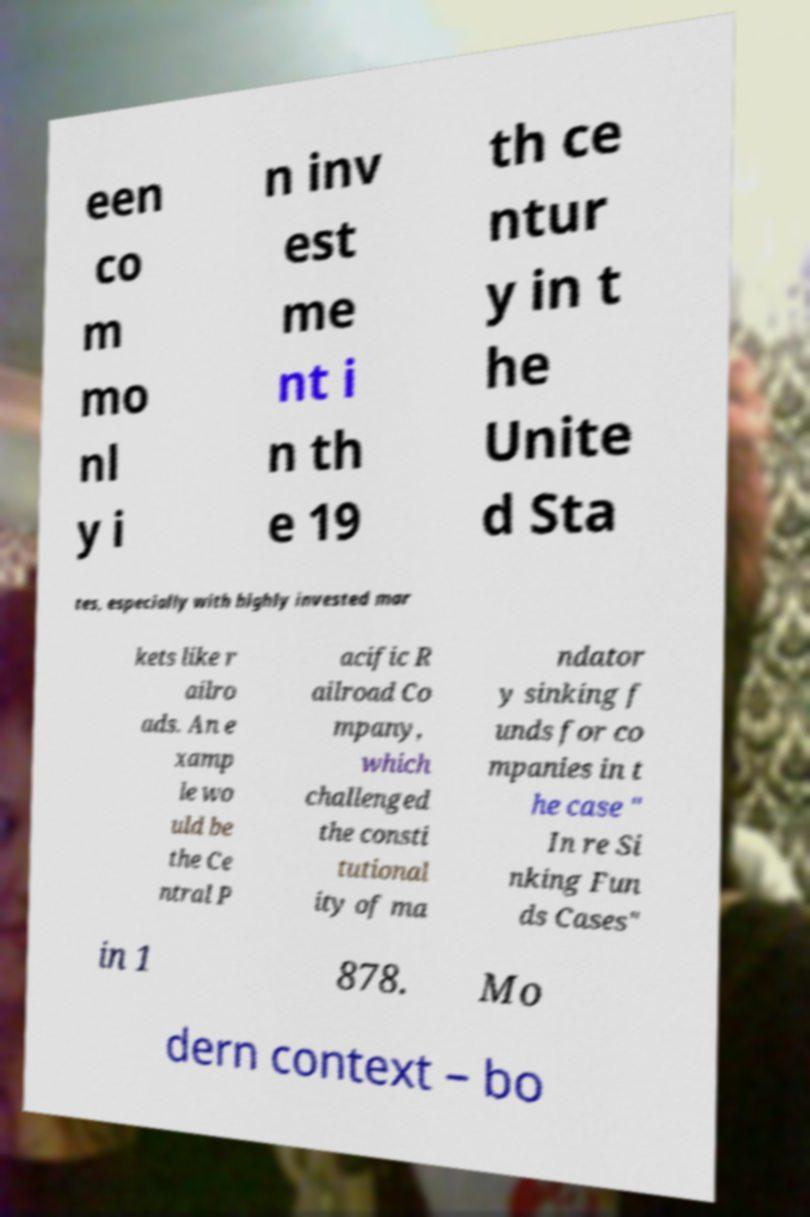Can you accurately transcribe the text from the provided image for me? een co m mo nl y i n inv est me nt i n th e 19 th ce ntur y in t he Unite d Sta tes, especially with highly invested mar kets like r ailro ads. An e xamp le wo uld be the Ce ntral P acific R ailroad Co mpany, which challenged the consti tutional ity of ma ndator y sinking f unds for co mpanies in t he case " In re Si nking Fun ds Cases" in 1 878. Mo dern context – bo 